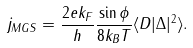Convert formula to latex. <formula><loc_0><loc_0><loc_500><loc_500>j _ { M G S } = \frac { 2 e k _ { F } } { h } \frac { \sin \phi } { 8 k _ { B } T } \langle D | \Delta | ^ { 2 } \rangle .</formula> 